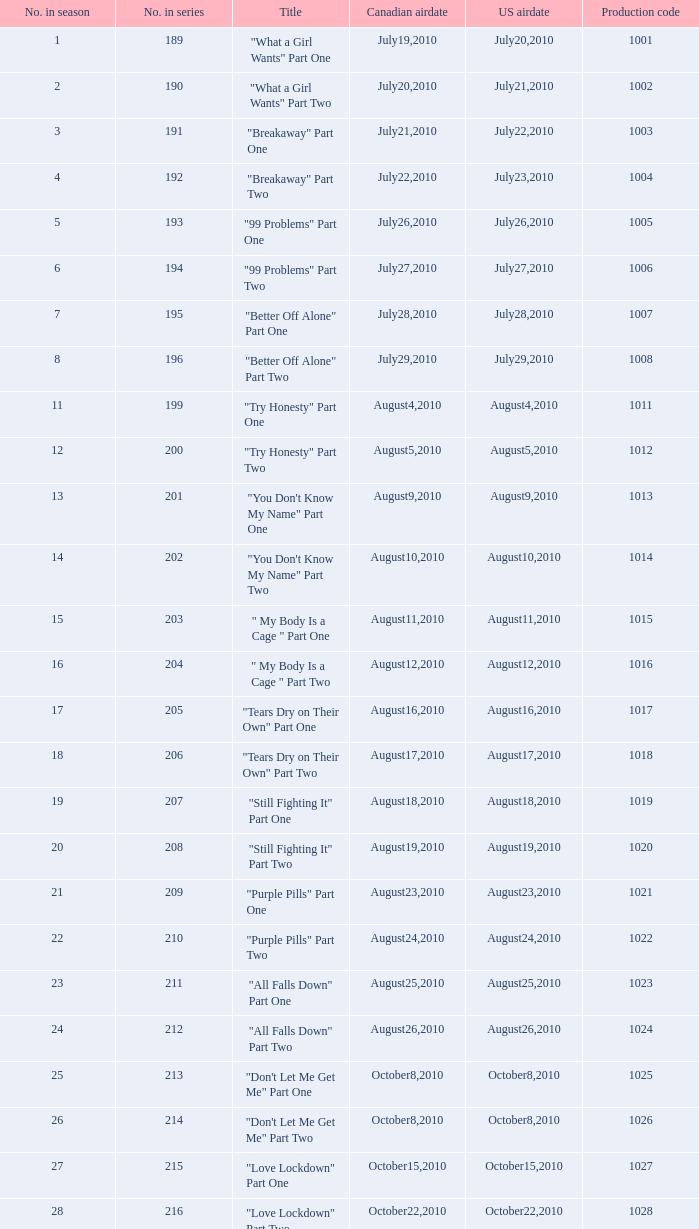How many titles held production code 1040? 1.0. Give me the full table as a dictionary. {'header': ['No. in season', 'No. in series', 'Title', 'Canadian airdate', 'US airdate', 'Production code'], 'rows': [['1', '189', '"What a Girl Wants" Part One', 'July19,2010', 'July20,2010', '1001'], ['2', '190', '"What a Girl Wants" Part Two', 'July20,2010', 'July21,2010', '1002'], ['3', '191', '"Breakaway" Part One', 'July21,2010', 'July22,2010', '1003'], ['4', '192', '"Breakaway" Part Two', 'July22,2010', 'July23,2010', '1004'], ['5', '193', '"99 Problems" Part One', 'July26,2010', 'July26,2010', '1005'], ['6', '194', '"99 Problems" Part Two', 'July27,2010', 'July27,2010', '1006'], ['7', '195', '"Better Off Alone" Part One', 'July28,2010', 'July28,2010', '1007'], ['8', '196', '"Better Off Alone" Part Two', 'July29,2010', 'July29,2010', '1008'], ['11', '199', '"Try Honesty" Part One', 'August4,2010', 'August4,2010', '1011'], ['12', '200', '"Try Honesty" Part Two', 'August5,2010', 'August5,2010', '1012'], ['13', '201', '"You Don\'t Know My Name" Part One', 'August9,2010', 'August9,2010', '1013'], ['14', '202', '"You Don\'t Know My Name" Part Two', 'August10,2010', 'August10,2010', '1014'], ['15', '203', '" My Body Is a Cage " Part One', 'August11,2010', 'August11,2010', '1015'], ['16', '204', '" My Body Is a Cage " Part Two', 'August12,2010', 'August12,2010', '1016'], ['17', '205', '"Tears Dry on Their Own" Part One', 'August16,2010', 'August16,2010', '1017'], ['18', '206', '"Tears Dry on Their Own" Part Two', 'August17,2010', 'August17,2010', '1018'], ['19', '207', '"Still Fighting It" Part One', 'August18,2010', 'August18,2010', '1019'], ['20', '208', '"Still Fighting It" Part Two', 'August19,2010', 'August19,2010', '1020'], ['21', '209', '"Purple Pills" Part One', 'August23,2010', 'August23,2010', '1021'], ['22', '210', '"Purple Pills" Part Two', 'August24,2010', 'August24,2010', '1022'], ['23', '211', '"All Falls Down" Part One', 'August25,2010', 'August25,2010', '1023'], ['24', '212', '"All Falls Down" Part Two', 'August26,2010', 'August26,2010', '1024'], ['25', '213', '"Don\'t Let Me Get Me" Part One', 'October8,2010', 'October8,2010', '1025'], ['26', '214', '"Don\'t Let Me Get Me" Part Two', 'October8,2010', 'October8,2010', '1026'], ['27', '215', '"Love Lockdown" Part One', 'October15,2010', 'October15,2010', '1027'], ['28', '216', '"Love Lockdown" Part Two', 'October22,2010', 'October22,2010', '1028'], ['29', '217', '"Umbrella" Part One', 'October29,2010', 'October29,2010', '1029'], ['30', '218', '"Umbrella" Part Two', 'November5,2010', 'November5,2010', '1030'], ['31', '219', '"Halo" Part One', 'November12,2010', 'November12,2010', '1031'], ['32', '220', '"Halo" Part Two', 'November19,2010', 'November19,2010', '1032'], ['33', '221', '"When Love Takes Over" Part One', 'February11,2011', 'February11,2011', '1033'], ['34', '222', '"When Love Takes Over" Part Two', 'February11,2011', 'February11,2011', '1034'], ['35', '223', '"The Way We Get By" Part One', 'February18,2011', 'February18,2011', '1035'], ['36', '224', '"The Way We Get By" Part Two', 'February25,2011', 'February25,2011', '1036'], ['37', '225', '"Jesus, Etc." Part One', 'March4,2011', 'March4,2011', '1037'], ['38', '226', '"Jesus, Etc." Part Two', 'March11,2011', 'March11,2011', '1038'], ['39', '227', '"Hide and Seek" Part One', 'March18,2011', 'March18,2011', '1039'], ['40', '228', '"Hide and Seek" Part Two', 'March25,2011', 'March25,2011', '1040'], ['41', '229', '"Chasing Pavements" Part One', 'April1,2011', 'April1,2011', '1041'], ['42', '230', '"Chasing Pavements" Part Two', 'April8,2011', 'April8,2011', '1042'], ['43', '231', '"Drop the World" Part One', 'April15,2011', 'April15,2011', '1043']]} 